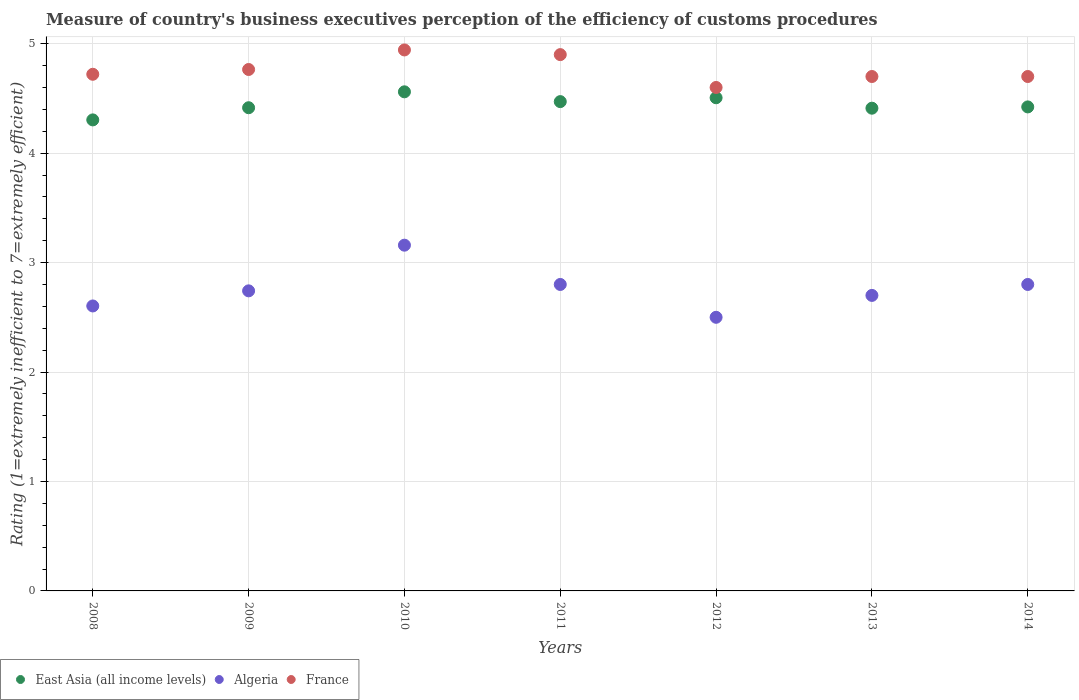Is the number of dotlines equal to the number of legend labels?
Your answer should be compact. Yes. What is the rating of the efficiency of customs procedure in France in 2010?
Your answer should be very brief. 4.94. Across all years, what is the maximum rating of the efficiency of customs procedure in East Asia (all income levels)?
Give a very brief answer. 4.56. Across all years, what is the minimum rating of the efficiency of customs procedure in France?
Provide a succinct answer. 4.6. In which year was the rating of the efficiency of customs procedure in France maximum?
Give a very brief answer. 2010. In which year was the rating of the efficiency of customs procedure in France minimum?
Keep it short and to the point. 2012. What is the total rating of the efficiency of customs procedure in Algeria in the graph?
Your response must be concise. 19.3. What is the difference between the rating of the efficiency of customs procedure in Algeria in 2012 and that in 2013?
Your answer should be compact. -0.2. What is the difference between the rating of the efficiency of customs procedure in Algeria in 2013 and the rating of the efficiency of customs procedure in East Asia (all income levels) in 2009?
Your answer should be very brief. -1.71. What is the average rating of the efficiency of customs procedure in France per year?
Your response must be concise. 4.76. In the year 2008, what is the difference between the rating of the efficiency of customs procedure in East Asia (all income levels) and rating of the efficiency of customs procedure in France?
Your response must be concise. -0.42. What is the ratio of the rating of the efficiency of customs procedure in Algeria in 2011 to that in 2013?
Provide a succinct answer. 1.04. Is the rating of the efficiency of customs procedure in East Asia (all income levels) in 2012 less than that in 2014?
Make the answer very short. No. Is the difference between the rating of the efficiency of customs procedure in East Asia (all income levels) in 2009 and 2011 greater than the difference between the rating of the efficiency of customs procedure in France in 2009 and 2011?
Keep it short and to the point. Yes. What is the difference between the highest and the second highest rating of the efficiency of customs procedure in East Asia (all income levels)?
Your response must be concise. 0.05. What is the difference between the highest and the lowest rating of the efficiency of customs procedure in East Asia (all income levels)?
Provide a short and direct response. 0.26. In how many years, is the rating of the efficiency of customs procedure in France greater than the average rating of the efficiency of customs procedure in France taken over all years?
Provide a short and direct response. 3. Is the sum of the rating of the efficiency of customs procedure in East Asia (all income levels) in 2010 and 2011 greater than the maximum rating of the efficiency of customs procedure in France across all years?
Offer a very short reply. Yes. Is it the case that in every year, the sum of the rating of the efficiency of customs procedure in Algeria and rating of the efficiency of customs procedure in East Asia (all income levels)  is greater than the rating of the efficiency of customs procedure in France?
Your answer should be very brief. Yes. What is the difference between two consecutive major ticks on the Y-axis?
Offer a terse response. 1. Are the values on the major ticks of Y-axis written in scientific E-notation?
Your answer should be compact. No. Does the graph contain grids?
Give a very brief answer. Yes. What is the title of the graph?
Your answer should be compact. Measure of country's business executives perception of the efficiency of customs procedures. Does "High income: nonOECD" appear as one of the legend labels in the graph?
Offer a terse response. No. What is the label or title of the Y-axis?
Keep it short and to the point. Rating (1=extremely inefficient to 7=extremely efficient). What is the Rating (1=extremely inefficient to 7=extremely efficient) in East Asia (all income levels) in 2008?
Make the answer very short. 4.3. What is the Rating (1=extremely inefficient to 7=extremely efficient) in Algeria in 2008?
Make the answer very short. 2.6. What is the Rating (1=extremely inefficient to 7=extremely efficient) of France in 2008?
Make the answer very short. 4.72. What is the Rating (1=extremely inefficient to 7=extremely efficient) in East Asia (all income levels) in 2009?
Provide a succinct answer. 4.41. What is the Rating (1=extremely inefficient to 7=extremely efficient) in Algeria in 2009?
Give a very brief answer. 2.74. What is the Rating (1=extremely inefficient to 7=extremely efficient) in France in 2009?
Ensure brevity in your answer.  4.76. What is the Rating (1=extremely inefficient to 7=extremely efficient) in East Asia (all income levels) in 2010?
Ensure brevity in your answer.  4.56. What is the Rating (1=extremely inefficient to 7=extremely efficient) of Algeria in 2010?
Ensure brevity in your answer.  3.16. What is the Rating (1=extremely inefficient to 7=extremely efficient) in France in 2010?
Offer a terse response. 4.94. What is the Rating (1=extremely inefficient to 7=extremely efficient) in East Asia (all income levels) in 2011?
Give a very brief answer. 4.47. What is the Rating (1=extremely inefficient to 7=extremely efficient) of Algeria in 2011?
Keep it short and to the point. 2.8. What is the Rating (1=extremely inefficient to 7=extremely efficient) of East Asia (all income levels) in 2012?
Keep it short and to the point. 4.51. What is the Rating (1=extremely inefficient to 7=extremely efficient) of Algeria in 2012?
Your answer should be very brief. 2.5. What is the Rating (1=extremely inefficient to 7=extremely efficient) of France in 2012?
Give a very brief answer. 4.6. What is the Rating (1=extremely inefficient to 7=extremely efficient) in East Asia (all income levels) in 2013?
Provide a short and direct response. 4.41. What is the Rating (1=extremely inefficient to 7=extremely efficient) of France in 2013?
Keep it short and to the point. 4.7. What is the Rating (1=extremely inefficient to 7=extremely efficient) in East Asia (all income levels) in 2014?
Offer a terse response. 4.42. Across all years, what is the maximum Rating (1=extremely inefficient to 7=extremely efficient) of East Asia (all income levels)?
Offer a very short reply. 4.56. Across all years, what is the maximum Rating (1=extremely inefficient to 7=extremely efficient) of Algeria?
Provide a short and direct response. 3.16. Across all years, what is the maximum Rating (1=extremely inefficient to 7=extremely efficient) in France?
Make the answer very short. 4.94. Across all years, what is the minimum Rating (1=extremely inefficient to 7=extremely efficient) in East Asia (all income levels)?
Give a very brief answer. 4.3. Across all years, what is the minimum Rating (1=extremely inefficient to 7=extremely efficient) in France?
Offer a terse response. 4.6. What is the total Rating (1=extremely inefficient to 7=extremely efficient) in East Asia (all income levels) in the graph?
Your answer should be very brief. 31.09. What is the total Rating (1=extremely inefficient to 7=extremely efficient) of Algeria in the graph?
Your answer should be compact. 19.3. What is the total Rating (1=extremely inefficient to 7=extremely efficient) of France in the graph?
Offer a terse response. 33.33. What is the difference between the Rating (1=extremely inefficient to 7=extremely efficient) of East Asia (all income levels) in 2008 and that in 2009?
Make the answer very short. -0.11. What is the difference between the Rating (1=extremely inefficient to 7=extremely efficient) in Algeria in 2008 and that in 2009?
Provide a succinct answer. -0.14. What is the difference between the Rating (1=extremely inefficient to 7=extremely efficient) of France in 2008 and that in 2009?
Give a very brief answer. -0.04. What is the difference between the Rating (1=extremely inefficient to 7=extremely efficient) of East Asia (all income levels) in 2008 and that in 2010?
Provide a short and direct response. -0.26. What is the difference between the Rating (1=extremely inefficient to 7=extremely efficient) of Algeria in 2008 and that in 2010?
Give a very brief answer. -0.56. What is the difference between the Rating (1=extremely inefficient to 7=extremely efficient) in France in 2008 and that in 2010?
Keep it short and to the point. -0.22. What is the difference between the Rating (1=extremely inefficient to 7=extremely efficient) of East Asia (all income levels) in 2008 and that in 2011?
Your answer should be compact. -0.17. What is the difference between the Rating (1=extremely inefficient to 7=extremely efficient) in Algeria in 2008 and that in 2011?
Give a very brief answer. -0.2. What is the difference between the Rating (1=extremely inefficient to 7=extremely efficient) of France in 2008 and that in 2011?
Ensure brevity in your answer.  -0.18. What is the difference between the Rating (1=extremely inefficient to 7=extremely efficient) in East Asia (all income levels) in 2008 and that in 2012?
Ensure brevity in your answer.  -0.2. What is the difference between the Rating (1=extremely inefficient to 7=extremely efficient) in Algeria in 2008 and that in 2012?
Your answer should be very brief. 0.1. What is the difference between the Rating (1=extremely inefficient to 7=extremely efficient) in France in 2008 and that in 2012?
Your answer should be very brief. 0.12. What is the difference between the Rating (1=extremely inefficient to 7=extremely efficient) of East Asia (all income levels) in 2008 and that in 2013?
Make the answer very short. -0.11. What is the difference between the Rating (1=extremely inefficient to 7=extremely efficient) in Algeria in 2008 and that in 2013?
Your answer should be compact. -0.1. What is the difference between the Rating (1=extremely inefficient to 7=extremely efficient) in France in 2008 and that in 2013?
Provide a short and direct response. 0.02. What is the difference between the Rating (1=extremely inefficient to 7=extremely efficient) of East Asia (all income levels) in 2008 and that in 2014?
Make the answer very short. -0.12. What is the difference between the Rating (1=extremely inefficient to 7=extremely efficient) in Algeria in 2008 and that in 2014?
Make the answer very short. -0.2. What is the difference between the Rating (1=extremely inefficient to 7=extremely efficient) of France in 2008 and that in 2014?
Make the answer very short. 0.02. What is the difference between the Rating (1=extremely inefficient to 7=extremely efficient) of East Asia (all income levels) in 2009 and that in 2010?
Your response must be concise. -0.15. What is the difference between the Rating (1=extremely inefficient to 7=extremely efficient) in Algeria in 2009 and that in 2010?
Your answer should be compact. -0.42. What is the difference between the Rating (1=extremely inefficient to 7=extremely efficient) of France in 2009 and that in 2010?
Offer a terse response. -0.18. What is the difference between the Rating (1=extremely inefficient to 7=extremely efficient) of East Asia (all income levels) in 2009 and that in 2011?
Give a very brief answer. -0.06. What is the difference between the Rating (1=extremely inefficient to 7=extremely efficient) in Algeria in 2009 and that in 2011?
Keep it short and to the point. -0.06. What is the difference between the Rating (1=extremely inefficient to 7=extremely efficient) in France in 2009 and that in 2011?
Your answer should be compact. -0.14. What is the difference between the Rating (1=extremely inefficient to 7=extremely efficient) in East Asia (all income levels) in 2009 and that in 2012?
Give a very brief answer. -0.09. What is the difference between the Rating (1=extremely inefficient to 7=extremely efficient) of Algeria in 2009 and that in 2012?
Your answer should be very brief. 0.24. What is the difference between the Rating (1=extremely inefficient to 7=extremely efficient) in France in 2009 and that in 2012?
Provide a short and direct response. 0.16. What is the difference between the Rating (1=extremely inefficient to 7=extremely efficient) in East Asia (all income levels) in 2009 and that in 2013?
Keep it short and to the point. 0. What is the difference between the Rating (1=extremely inefficient to 7=extremely efficient) of Algeria in 2009 and that in 2013?
Keep it short and to the point. 0.04. What is the difference between the Rating (1=extremely inefficient to 7=extremely efficient) of France in 2009 and that in 2013?
Make the answer very short. 0.06. What is the difference between the Rating (1=extremely inefficient to 7=extremely efficient) of East Asia (all income levels) in 2009 and that in 2014?
Ensure brevity in your answer.  -0.01. What is the difference between the Rating (1=extremely inefficient to 7=extremely efficient) of Algeria in 2009 and that in 2014?
Offer a very short reply. -0.06. What is the difference between the Rating (1=extremely inefficient to 7=extremely efficient) of France in 2009 and that in 2014?
Ensure brevity in your answer.  0.06. What is the difference between the Rating (1=extremely inefficient to 7=extremely efficient) in East Asia (all income levels) in 2010 and that in 2011?
Provide a succinct answer. 0.09. What is the difference between the Rating (1=extremely inefficient to 7=extremely efficient) in Algeria in 2010 and that in 2011?
Your answer should be very brief. 0.36. What is the difference between the Rating (1=extremely inefficient to 7=extremely efficient) in France in 2010 and that in 2011?
Make the answer very short. 0.04. What is the difference between the Rating (1=extremely inefficient to 7=extremely efficient) in East Asia (all income levels) in 2010 and that in 2012?
Provide a succinct answer. 0.05. What is the difference between the Rating (1=extremely inefficient to 7=extremely efficient) of Algeria in 2010 and that in 2012?
Your answer should be very brief. 0.66. What is the difference between the Rating (1=extremely inefficient to 7=extremely efficient) of France in 2010 and that in 2012?
Your answer should be very brief. 0.34. What is the difference between the Rating (1=extremely inefficient to 7=extremely efficient) of East Asia (all income levels) in 2010 and that in 2013?
Provide a short and direct response. 0.15. What is the difference between the Rating (1=extremely inefficient to 7=extremely efficient) of Algeria in 2010 and that in 2013?
Your answer should be compact. 0.46. What is the difference between the Rating (1=extremely inefficient to 7=extremely efficient) in France in 2010 and that in 2013?
Keep it short and to the point. 0.24. What is the difference between the Rating (1=extremely inefficient to 7=extremely efficient) of East Asia (all income levels) in 2010 and that in 2014?
Keep it short and to the point. 0.14. What is the difference between the Rating (1=extremely inefficient to 7=extremely efficient) in Algeria in 2010 and that in 2014?
Offer a terse response. 0.36. What is the difference between the Rating (1=extremely inefficient to 7=extremely efficient) in France in 2010 and that in 2014?
Keep it short and to the point. 0.24. What is the difference between the Rating (1=extremely inefficient to 7=extremely efficient) of East Asia (all income levels) in 2011 and that in 2012?
Your answer should be very brief. -0.04. What is the difference between the Rating (1=extremely inefficient to 7=extremely efficient) in Algeria in 2011 and that in 2012?
Offer a terse response. 0.3. What is the difference between the Rating (1=extremely inefficient to 7=extremely efficient) in France in 2011 and that in 2012?
Make the answer very short. 0.3. What is the difference between the Rating (1=extremely inefficient to 7=extremely efficient) in East Asia (all income levels) in 2011 and that in 2013?
Keep it short and to the point. 0.06. What is the difference between the Rating (1=extremely inefficient to 7=extremely efficient) of Algeria in 2011 and that in 2013?
Keep it short and to the point. 0.1. What is the difference between the Rating (1=extremely inefficient to 7=extremely efficient) of East Asia (all income levels) in 2011 and that in 2014?
Your answer should be compact. 0.05. What is the difference between the Rating (1=extremely inefficient to 7=extremely efficient) in France in 2011 and that in 2014?
Make the answer very short. 0.2. What is the difference between the Rating (1=extremely inefficient to 7=extremely efficient) in East Asia (all income levels) in 2012 and that in 2013?
Provide a short and direct response. 0.1. What is the difference between the Rating (1=extremely inefficient to 7=extremely efficient) of Algeria in 2012 and that in 2013?
Your answer should be compact. -0.2. What is the difference between the Rating (1=extremely inefficient to 7=extremely efficient) in East Asia (all income levels) in 2012 and that in 2014?
Offer a terse response. 0.08. What is the difference between the Rating (1=extremely inefficient to 7=extremely efficient) in East Asia (all income levels) in 2013 and that in 2014?
Make the answer very short. -0.01. What is the difference between the Rating (1=extremely inefficient to 7=extremely efficient) in East Asia (all income levels) in 2008 and the Rating (1=extremely inefficient to 7=extremely efficient) in Algeria in 2009?
Provide a succinct answer. 1.56. What is the difference between the Rating (1=extremely inefficient to 7=extremely efficient) of East Asia (all income levels) in 2008 and the Rating (1=extremely inefficient to 7=extremely efficient) of France in 2009?
Offer a very short reply. -0.46. What is the difference between the Rating (1=extremely inefficient to 7=extremely efficient) of Algeria in 2008 and the Rating (1=extremely inefficient to 7=extremely efficient) of France in 2009?
Ensure brevity in your answer.  -2.16. What is the difference between the Rating (1=extremely inefficient to 7=extremely efficient) of East Asia (all income levels) in 2008 and the Rating (1=extremely inefficient to 7=extremely efficient) of Algeria in 2010?
Your response must be concise. 1.14. What is the difference between the Rating (1=extremely inefficient to 7=extremely efficient) of East Asia (all income levels) in 2008 and the Rating (1=extremely inefficient to 7=extremely efficient) of France in 2010?
Provide a short and direct response. -0.64. What is the difference between the Rating (1=extremely inefficient to 7=extremely efficient) of Algeria in 2008 and the Rating (1=extremely inefficient to 7=extremely efficient) of France in 2010?
Provide a short and direct response. -2.34. What is the difference between the Rating (1=extremely inefficient to 7=extremely efficient) of East Asia (all income levels) in 2008 and the Rating (1=extremely inefficient to 7=extremely efficient) of Algeria in 2011?
Your response must be concise. 1.5. What is the difference between the Rating (1=extremely inefficient to 7=extremely efficient) in East Asia (all income levels) in 2008 and the Rating (1=extremely inefficient to 7=extremely efficient) in France in 2011?
Give a very brief answer. -0.6. What is the difference between the Rating (1=extremely inefficient to 7=extremely efficient) of Algeria in 2008 and the Rating (1=extremely inefficient to 7=extremely efficient) of France in 2011?
Offer a very short reply. -2.3. What is the difference between the Rating (1=extremely inefficient to 7=extremely efficient) of East Asia (all income levels) in 2008 and the Rating (1=extremely inefficient to 7=extremely efficient) of Algeria in 2012?
Give a very brief answer. 1.8. What is the difference between the Rating (1=extremely inefficient to 7=extremely efficient) of East Asia (all income levels) in 2008 and the Rating (1=extremely inefficient to 7=extremely efficient) of France in 2012?
Offer a very short reply. -0.3. What is the difference between the Rating (1=extremely inefficient to 7=extremely efficient) of Algeria in 2008 and the Rating (1=extremely inefficient to 7=extremely efficient) of France in 2012?
Offer a terse response. -2. What is the difference between the Rating (1=extremely inefficient to 7=extremely efficient) in East Asia (all income levels) in 2008 and the Rating (1=extremely inefficient to 7=extremely efficient) in Algeria in 2013?
Your response must be concise. 1.6. What is the difference between the Rating (1=extremely inefficient to 7=extremely efficient) in East Asia (all income levels) in 2008 and the Rating (1=extremely inefficient to 7=extremely efficient) in France in 2013?
Keep it short and to the point. -0.4. What is the difference between the Rating (1=extremely inefficient to 7=extremely efficient) of Algeria in 2008 and the Rating (1=extremely inefficient to 7=extremely efficient) of France in 2013?
Make the answer very short. -2.1. What is the difference between the Rating (1=extremely inefficient to 7=extremely efficient) in East Asia (all income levels) in 2008 and the Rating (1=extremely inefficient to 7=extremely efficient) in Algeria in 2014?
Your answer should be compact. 1.5. What is the difference between the Rating (1=extremely inefficient to 7=extremely efficient) in East Asia (all income levels) in 2008 and the Rating (1=extremely inefficient to 7=extremely efficient) in France in 2014?
Offer a very short reply. -0.4. What is the difference between the Rating (1=extremely inefficient to 7=extremely efficient) in Algeria in 2008 and the Rating (1=extremely inefficient to 7=extremely efficient) in France in 2014?
Give a very brief answer. -2.1. What is the difference between the Rating (1=extremely inefficient to 7=extremely efficient) in East Asia (all income levels) in 2009 and the Rating (1=extremely inefficient to 7=extremely efficient) in Algeria in 2010?
Provide a short and direct response. 1.26. What is the difference between the Rating (1=extremely inefficient to 7=extremely efficient) of East Asia (all income levels) in 2009 and the Rating (1=extremely inefficient to 7=extremely efficient) of France in 2010?
Keep it short and to the point. -0.53. What is the difference between the Rating (1=extremely inefficient to 7=extremely efficient) of Algeria in 2009 and the Rating (1=extremely inefficient to 7=extremely efficient) of France in 2010?
Provide a succinct answer. -2.2. What is the difference between the Rating (1=extremely inefficient to 7=extremely efficient) of East Asia (all income levels) in 2009 and the Rating (1=extremely inefficient to 7=extremely efficient) of Algeria in 2011?
Your answer should be compact. 1.61. What is the difference between the Rating (1=extremely inefficient to 7=extremely efficient) of East Asia (all income levels) in 2009 and the Rating (1=extremely inefficient to 7=extremely efficient) of France in 2011?
Ensure brevity in your answer.  -0.49. What is the difference between the Rating (1=extremely inefficient to 7=extremely efficient) in Algeria in 2009 and the Rating (1=extremely inefficient to 7=extremely efficient) in France in 2011?
Your response must be concise. -2.16. What is the difference between the Rating (1=extremely inefficient to 7=extremely efficient) in East Asia (all income levels) in 2009 and the Rating (1=extremely inefficient to 7=extremely efficient) in Algeria in 2012?
Keep it short and to the point. 1.91. What is the difference between the Rating (1=extremely inefficient to 7=extremely efficient) of East Asia (all income levels) in 2009 and the Rating (1=extremely inefficient to 7=extremely efficient) of France in 2012?
Ensure brevity in your answer.  -0.19. What is the difference between the Rating (1=extremely inefficient to 7=extremely efficient) in Algeria in 2009 and the Rating (1=extremely inefficient to 7=extremely efficient) in France in 2012?
Give a very brief answer. -1.86. What is the difference between the Rating (1=extremely inefficient to 7=extremely efficient) of East Asia (all income levels) in 2009 and the Rating (1=extremely inefficient to 7=extremely efficient) of Algeria in 2013?
Provide a succinct answer. 1.71. What is the difference between the Rating (1=extremely inefficient to 7=extremely efficient) in East Asia (all income levels) in 2009 and the Rating (1=extremely inefficient to 7=extremely efficient) in France in 2013?
Offer a terse response. -0.29. What is the difference between the Rating (1=extremely inefficient to 7=extremely efficient) of Algeria in 2009 and the Rating (1=extremely inefficient to 7=extremely efficient) of France in 2013?
Provide a short and direct response. -1.96. What is the difference between the Rating (1=extremely inefficient to 7=extremely efficient) in East Asia (all income levels) in 2009 and the Rating (1=extremely inefficient to 7=extremely efficient) in Algeria in 2014?
Offer a terse response. 1.61. What is the difference between the Rating (1=extremely inefficient to 7=extremely efficient) in East Asia (all income levels) in 2009 and the Rating (1=extremely inefficient to 7=extremely efficient) in France in 2014?
Offer a very short reply. -0.29. What is the difference between the Rating (1=extremely inefficient to 7=extremely efficient) of Algeria in 2009 and the Rating (1=extremely inefficient to 7=extremely efficient) of France in 2014?
Ensure brevity in your answer.  -1.96. What is the difference between the Rating (1=extremely inefficient to 7=extremely efficient) of East Asia (all income levels) in 2010 and the Rating (1=extremely inefficient to 7=extremely efficient) of Algeria in 2011?
Offer a terse response. 1.76. What is the difference between the Rating (1=extremely inefficient to 7=extremely efficient) of East Asia (all income levels) in 2010 and the Rating (1=extremely inefficient to 7=extremely efficient) of France in 2011?
Ensure brevity in your answer.  -0.34. What is the difference between the Rating (1=extremely inefficient to 7=extremely efficient) of Algeria in 2010 and the Rating (1=extremely inefficient to 7=extremely efficient) of France in 2011?
Give a very brief answer. -1.74. What is the difference between the Rating (1=extremely inefficient to 7=extremely efficient) in East Asia (all income levels) in 2010 and the Rating (1=extremely inefficient to 7=extremely efficient) in Algeria in 2012?
Provide a succinct answer. 2.06. What is the difference between the Rating (1=extremely inefficient to 7=extremely efficient) of East Asia (all income levels) in 2010 and the Rating (1=extremely inefficient to 7=extremely efficient) of France in 2012?
Provide a short and direct response. -0.04. What is the difference between the Rating (1=extremely inefficient to 7=extremely efficient) of Algeria in 2010 and the Rating (1=extremely inefficient to 7=extremely efficient) of France in 2012?
Your answer should be very brief. -1.44. What is the difference between the Rating (1=extremely inefficient to 7=extremely efficient) in East Asia (all income levels) in 2010 and the Rating (1=extremely inefficient to 7=extremely efficient) in Algeria in 2013?
Provide a short and direct response. 1.86. What is the difference between the Rating (1=extremely inefficient to 7=extremely efficient) of East Asia (all income levels) in 2010 and the Rating (1=extremely inefficient to 7=extremely efficient) of France in 2013?
Provide a succinct answer. -0.14. What is the difference between the Rating (1=extremely inefficient to 7=extremely efficient) in Algeria in 2010 and the Rating (1=extremely inefficient to 7=extremely efficient) in France in 2013?
Make the answer very short. -1.54. What is the difference between the Rating (1=extremely inefficient to 7=extremely efficient) of East Asia (all income levels) in 2010 and the Rating (1=extremely inefficient to 7=extremely efficient) of Algeria in 2014?
Make the answer very short. 1.76. What is the difference between the Rating (1=extremely inefficient to 7=extremely efficient) of East Asia (all income levels) in 2010 and the Rating (1=extremely inefficient to 7=extremely efficient) of France in 2014?
Keep it short and to the point. -0.14. What is the difference between the Rating (1=extremely inefficient to 7=extremely efficient) of Algeria in 2010 and the Rating (1=extremely inefficient to 7=extremely efficient) of France in 2014?
Keep it short and to the point. -1.54. What is the difference between the Rating (1=extremely inefficient to 7=extremely efficient) in East Asia (all income levels) in 2011 and the Rating (1=extremely inefficient to 7=extremely efficient) in Algeria in 2012?
Keep it short and to the point. 1.97. What is the difference between the Rating (1=extremely inefficient to 7=extremely efficient) in East Asia (all income levels) in 2011 and the Rating (1=extremely inefficient to 7=extremely efficient) in France in 2012?
Your response must be concise. -0.13. What is the difference between the Rating (1=extremely inefficient to 7=extremely efficient) in East Asia (all income levels) in 2011 and the Rating (1=extremely inefficient to 7=extremely efficient) in Algeria in 2013?
Your response must be concise. 1.77. What is the difference between the Rating (1=extremely inefficient to 7=extremely efficient) of East Asia (all income levels) in 2011 and the Rating (1=extremely inefficient to 7=extremely efficient) of France in 2013?
Give a very brief answer. -0.23. What is the difference between the Rating (1=extremely inefficient to 7=extremely efficient) in Algeria in 2011 and the Rating (1=extremely inefficient to 7=extremely efficient) in France in 2013?
Your answer should be compact. -1.9. What is the difference between the Rating (1=extremely inefficient to 7=extremely efficient) in East Asia (all income levels) in 2011 and the Rating (1=extremely inefficient to 7=extremely efficient) in Algeria in 2014?
Offer a terse response. 1.67. What is the difference between the Rating (1=extremely inefficient to 7=extremely efficient) of East Asia (all income levels) in 2011 and the Rating (1=extremely inefficient to 7=extremely efficient) of France in 2014?
Keep it short and to the point. -0.23. What is the difference between the Rating (1=extremely inefficient to 7=extremely efficient) in East Asia (all income levels) in 2012 and the Rating (1=extremely inefficient to 7=extremely efficient) in Algeria in 2013?
Your answer should be very brief. 1.81. What is the difference between the Rating (1=extremely inefficient to 7=extremely efficient) of East Asia (all income levels) in 2012 and the Rating (1=extremely inefficient to 7=extremely efficient) of France in 2013?
Keep it short and to the point. -0.19. What is the difference between the Rating (1=extremely inefficient to 7=extremely efficient) in East Asia (all income levels) in 2012 and the Rating (1=extremely inefficient to 7=extremely efficient) in Algeria in 2014?
Offer a very short reply. 1.71. What is the difference between the Rating (1=extremely inefficient to 7=extremely efficient) of East Asia (all income levels) in 2012 and the Rating (1=extremely inefficient to 7=extremely efficient) of France in 2014?
Offer a terse response. -0.19. What is the difference between the Rating (1=extremely inefficient to 7=extremely efficient) in East Asia (all income levels) in 2013 and the Rating (1=extremely inefficient to 7=extremely efficient) in Algeria in 2014?
Your response must be concise. 1.61. What is the difference between the Rating (1=extremely inefficient to 7=extremely efficient) of East Asia (all income levels) in 2013 and the Rating (1=extremely inefficient to 7=extremely efficient) of France in 2014?
Your response must be concise. -0.29. What is the difference between the Rating (1=extremely inefficient to 7=extremely efficient) of Algeria in 2013 and the Rating (1=extremely inefficient to 7=extremely efficient) of France in 2014?
Ensure brevity in your answer.  -2. What is the average Rating (1=extremely inefficient to 7=extremely efficient) in East Asia (all income levels) per year?
Make the answer very short. 4.44. What is the average Rating (1=extremely inefficient to 7=extremely efficient) of Algeria per year?
Your response must be concise. 2.76. What is the average Rating (1=extremely inefficient to 7=extremely efficient) in France per year?
Offer a very short reply. 4.76. In the year 2008, what is the difference between the Rating (1=extremely inefficient to 7=extremely efficient) of East Asia (all income levels) and Rating (1=extremely inefficient to 7=extremely efficient) of Algeria?
Give a very brief answer. 1.7. In the year 2008, what is the difference between the Rating (1=extremely inefficient to 7=extremely efficient) of East Asia (all income levels) and Rating (1=extremely inefficient to 7=extremely efficient) of France?
Provide a short and direct response. -0.42. In the year 2008, what is the difference between the Rating (1=extremely inefficient to 7=extremely efficient) in Algeria and Rating (1=extremely inefficient to 7=extremely efficient) in France?
Give a very brief answer. -2.12. In the year 2009, what is the difference between the Rating (1=extremely inefficient to 7=extremely efficient) of East Asia (all income levels) and Rating (1=extremely inefficient to 7=extremely efficient) of Algeria?
Ensure brevity in your answer.  1.67. In the year 2009, what is the difference between the Rating (1=extremely inefficient to 7=extremely efficient) of East Asia (all income levels) and Rating (1=extremely inefficient to 7=extremely efficient) of France?
Offer a terse response. -0.35. In the year 2009, what is the difference between the Rating (1=extremely inefficient to 7=extremely efficient) in Algeria and Rating (1=extremely inefficient to 7=extremely efficient) in France?
Keep it short and to the point. -2.02. In the year 2010, what is the difference between the Rating (1=extremely inefficient to 7=extremely efficient) in East Asia (all income levels) and Rating (1=extremely inefficient to 7=extremely efficient) in Algeria?
Ensure brevity in your answer.  1.4. In the year 2010, what is the difference between the Rating (1=extremely inefficient to 7=extremely efficient) in East Asia (all income levels) and Rating (1=extremely inefficient to 7=extremely efficient) in France?
Your response must be concise. -0.38. In the year 2010, what is the difference between the Rating (1=extremely inefficient to 7=extremely efficient) of Algeria and Rating (1=extremely inefficient to 7=extremely efficient) of France?
Provide a succinct answer. -1.78. In the year 2011, what is the difference between the Rating (1=extremely inefficient to 7=extremely efficient) in East Asia (all income levels) and Rating (1=extremely inefficient to 7=extremely efficient) in Algeria?
Provide a succinct answer. 1.67. In the year 2011, what is the difference between the Rating (1=extremely inefficient to 7=extremely efficient) in East Asia (all income levels) and Rating (1=extremely inefficient to 7=extremely efficient) in France?
Provide a succinct answer. -0.43. In the year 2012, what is the difference between the Rating (1=extremely inefficient to 7=extremely efficient) in East Asia (all income levels) and Rating (1=extremely inefficient to 7=extremely efficient) in Algeria?
Provide a short and direct response. 2.01. In the year 2012, what is the difference between the Rating (1=extremely inefficient to 7=extremely efficient) of East Asia (all income levels) and Rating (1=extremely inefficient to 7=extremely efficient) of France?
Your response must be concise. -0.09. In the year 2013, what is the difference between the Rating (1=extremely inefficient to 7=extremely efficient) in East Asia (all income levels) and Rating (1=extremely inefficient to 7=extremely efficient) in Algeria?
Your answer should be compact. 1.71. In the year 2013, what is the difference between the Rating (1=extremely inefficient to 7=extremely efficient) in East Asia (all income levels) and Rating (1=extremely inefficient to 7=extremely efficient) in France?
Ensure brevity in your answer.  -0.29. In the year 2013, what is the difference between the Rating (1=extremely inefficient to 7=extremely efficient) in Algeria and Rating (1=extremely inefficient to 7=extremely efficient) in France?
Keep it short and to the point. -2. In the year 2014, what is the difference between the Rating (1=extremely inefficient to 7=extremely efficient) in East Asia (all income levels) and Rating (1=extremely inefficient to 7=extremely efficient) in Algeria?
Your answer should be very brief. 1.62. In the year 2014, what is the difference between the Rating (1=extremely inefficient to 7=extremely efficient) in East Asia (all income levels) and Rating (1=extremely inefficient to 7=extremely efficient) in France?
Your answer should be very brief. -0.28. In the year 2014, what is the difference between the Rating (1=extremely inefficient to 7=extremely efficient) in Algeria and Rating (1=extremely inefficient to 7=extremely efficient) in France?
Your response must be concise. -1.9. What is the ratio of the Rating (1=extremely inefficient to 7=extremely efficient) in East Asia (all income levels) in 2008 to that in 2009?
Your answer should be very brief. 0.97. What is the ratio of the Rating (1=extremely inefficient to 7=extremely efficient) in Algeria in 2008 to that in 2009?
Provide a short and direct response. 0.95. What is the ratio of the Rating (1=extremely inefficient to 7=extremely efficient) of East Asia (all income levels) in 2008 to that in 2010?
Offer a terse response. 0.94. What is the ratio of the Rating (1=extremely inefficient to 7=extremely efficient) in Algeria in 2008 to that in 2010?
Provide a short and direct response. 0.82. What is the ratio of the Rating (1=extremely inefficient to 7=extremely efficient) of France in 2008 to that in 2010?
Your response must be concise. 0.95. What is the ratio of the Rating (1=extremely inefficient to 7=extremely efficient) of East Asia (all income levels) in 2008 to that in 2011?
Make the answer very short. 0.96. What is the ratio of the Rating (1=extremely inefficient to 7=extremely efficient) in Algeria in 2008 to that in 2011?
Provide a short and direct response. 0.93. What is the ratio of the Rating (1=extremely inefficient to 7=extremely efficient) in France in 2008 to that in 2011?
Ensure brevity in your answer.  0.96. What is the ratio of the Rating (1=extremely inefficient to 7=extremely efficient) of East Asia (all income levels) in 2008 to that in 2012?
Ensure brevity in your answer.  0.96. What is the ratio of the Rating (1=extremely inefficient to 7=extremely efficient) in Algeria in 2008 to that in 2012?
Provide a succinct answer. 1.04. What is the ratio of the Rating (1=extremely inefficient to 7=extremely efficient) in France in 2008 to that in 2012?
Provide a succinct answer. 1.03. What is the ratio of the Rating (1=extremely inefficient to 7=extremely efficient) in East Asia (all income levels) in 2008 to that in 2013?
Make the answer very short. 0.98. What is the ratio of the Rating (1=extremely inefficient to 7=extremely efficient) in France in 2008 to that in 2013?
Offer a very short reply. 1. What is the ratio of the Rating (1=extremely inefficient to 7=extremely efficient) in East Asia (all income levels) in 2008 to that in 2014?
Provide a short and direct response. 0.97. What is the ratio of the Rating (1=extremely inefficient to 7=extremely efficient) of Algeria in 2008 to that in 2014?
Offer a terse response. 0.93. What is the ratio of the Rating (1=extremely inefficient to 7=extremely efficient) of France in 2008 to that in 2014?
Make the answer very short. 1. What is the ratio of the Rating (1=extremely inefficient to 7=extremely efficient) of East Asia (all income levels) in 2009 to that in 2010?
Provide a succinct answer. 0.97. What is the ratio of the Rating (1=extremely inefficient to 7=extremely efficient) in Algeria in 2009 to that in 2010?
Ensure brevity in your answer.  0.87. What is the ratio of the Rating (1=extremely inefficient to 7=extremely efficient) in France in 2009 to that in 2010?
Give a very brief answer. 0.96. What is the ratio of the Rating (1=extremely inefficient to 7=extremely efficient) of East Asia (all income levels) in 2009 to that in 2011?
Make the answer very short. 0.99. What is the ratio of the Rating (1=extremely inefficient to 7=extremely efficient) of Algeria in 2009 to that in 2011?
Provide a short and direct response. 0.98. What is the ratio of the Rating (1=extremely inefficient to 7=extremely efficient) in France in 2009 to that in 2011?
Provide a succinct answer. 0.97. What is the ratio of the Rating (1=extremely inefficient to 7=extremely efficient) in East Asia (all income levels) in 2009 to that in 2012?
Make the answer very short. 0.98. What is the ratio of the Rating (1=extremely inefficient to 7=extremely efficient) of Algeria in 2009 to that in 2012?
Your answer should be very brief. 1.1. What is the ratio of the Rating (1=extremely inefficient to 7=extremely efficient) in France in 2009 to that in 2012?
Make the answer very short. 1.04. What is the ratio of the Rating (1=extremely inefficient to 7=extremely efficient) of Algeria in 2009 to that in 2013?
Provide a succinct answer. 1.02. What is the ratio of the Rating (1=extremely inefficient to 7=extremely efficient) of France in 2009 to that in 2013?
Keep it short and to the point. 1.01. What is the ratio of the Rating (1=extremely inefficient to 7=extremely efficient) in Algeria in 2009 to that in 2014?
Keep it short and to the point. 0.98. What is the ratio of the Rating (1=extremely inefficient to 7=extremely efficient) in France in 2009 to that in 2014?
Ensure brevity in your answer.  1.01. What is the ratio of the Rating (1=extremely inefficient to 7=extremely efficient) of East Asia (all income levels) in 2010 to that in 2011?
Make the answer very short. 1.02. What is the ratio of the Rating (1=extremely inefficient to 7=extremely efficient) in Algeria in 2010 to that in 2011?
Your answer should be very brief. 1.13. What is the ratio of the Rating (1=extremely inefficient to 7=extremely efficient) of France in 2010 to that in 2011?
Your answer should be compact. 1.01. What is the ratio of the Rating (1=extremely inefficient to 7=extremely efficient) of Algeria in 2010 to that in 2012?
Offer a very short reply. 1.26. What is the ratio of the Rating (1=extremely inefficient to 7=extremely efficient) in France in 2010 to that in 2012?
Your answer should be compact. 1.07. What is the ratio of the Rating (1=extremely inefficient to 7=extremely efficient) in East Asia (all income levels) in 2010 to that in 2013?
Keep it short and to the point. 1.03. What is the ratio of the Rating (1=extremely inefficient to 7=extremely efficient) of Algeria in 2010 to that in 2013?
Ensure brevity in your answer.  1.17. What is the ratio of the Rating (1=extremely inefficient to 7=extremely efficient) in France in 2010 to that in 2013?
Ensure brevity in your answer.  1.05. What is the ratio of the Rating (1=extremely inefficient to 7=extremely efficient) of East Asia (all income levels) in 2010 to that in 2014?
Provide a succinct answer. 1.03. What is the ratio of the Rating (1=extremely inefficient to 7=extremely efficient) of Algeria in 2010 to that in 2014?
Offer a very short reply. 1.13. What is the ratio of the Rating (1=extremely inefficient to 7=extremely efficient) in France in 2010 to that in 2014?
Give a very brief answer. 1.05. What is the ratio of the Rating (1=extremely inefficient to 7=extremely efficient) in East Asia (all income levels) in 2011 to that in 2012?
Keep it short and to the point. 0.99. What is the ratio of the Rating (1=extremely inefficient to 7=extremely efficient) of Algeria in 2011 to that in 2012?
Keep it short and to the point. 1.12. What is the ratio of the Rating (1=extremely inefficient to 7=extremely efficient) of France in 2011 to that in 2012?
Your response must be concise. 1.07. What is the ratio of the Rating (1=extremely inefficient to 7=extremely efficient) in East Asia (all income levels) in 2011 to that in 2013?
Offer a terse response. 1.01. What is the ratio of the Rating (1=extremely inefficient to 7=extremely efficient) in France in 2011 to that in 2013?
Offer a terse response. 1.04. What is the ratio of the Rating (1=extremely inefficient to 7=extremely efficient) in East Asia (all income levels) in 2011 to that in 2014?
Provide a succinct answer. 1.01. What is the ratio of the Rating (1=extremely inefficient to 7=extremely efficient) of Algeria in 2011 to that in 2014?
Provide a succinct answer. 1. What is the ratio of the Rating (1=extremely inefficient to 7=extremely efficient) in France in 2011 to that in 2014?
Make the answer very short. 1.04. What is the ratio of the Rating (1=extremely inefficient to 7=extremely efficient) in East Asia (all income levels) in 2012 to that in 2013?
Keep it short and to the point. 1.02. What is the ratio of the Rating (1=extremely inefficient to 7=extremely efficient) of Algeria in 2012 to that in 2013?
Make the answer very short. 0.93. What is the ratio of the Rating (1=extremely inefficient to 7=extremely efficient) in France in 2012 to that in 2013?
Give a very brief answer. 0.98. What is the ratio of the Rating (1=extremely inefficient to 7=extremely efficient) of East Asia (all income levels) in 2012 to that in 2014?
Make the answer very short. 1.02. What is the ratio of the Rating (1=extremely inefficient to 7=extremely efficient) in Algeria in 2012 to that in 2014?
Provide a short and direct response. 0.89. What is the ratio of the Rating (1=extremely inefficient to 7=extremely efficient) of France in 2012 to that in 2014?
Offer a very short reply. 0.98. What is the ratio of the Rating (1=extremely inefficient to 7=extremely efficient) in East Asia (all income levels) in 2013 to that in 2014?
Ensure brevity in your answer.  1. What is the ratio of the Rating (1=extremely inefficient to 7=extremely efficient) of Algeria in 2013 to that in 2014?
Offer a very short reply. 0.96. What is the ratio of the Rating (1=extremely inefficient to 7=extremely efficient) in France in 2013 to that in 2014?
Provide a succinct answer. 1. What is the difference between the highest and the second highest Rating (1=extremely inefficient to 7=extremely efficient) of East Asia (all income levels)?
Your answer should be compact. 0.05. What is the difference between the highest and the second highest Rating (1=extremely inefficient to 7=extremely efficient) in Algeria?
Make the answer very short. 0.36. What is the difference between the highest and the second highest Rating (1=extremely inefficient to 7=extremely efficient) of France?
Keep it short and to the point. 0.04. What is the difference between the highest and the lowest Rating (1=extremely inefficient to 7=extremely efficient) of East Asia (all income levels)?
Keep it short and to the point. 0.26. What is the difference between the highest and the lowest Rating (1=extremely inefficient to 7=extremely efficient) of Algeria?
Your answer should be compact. 0.66. What is the difference between the highest and the lowest Rating (1=extremely inefficient to 7=extremely efficient) in France?
Your response must be concise. 0.34. 